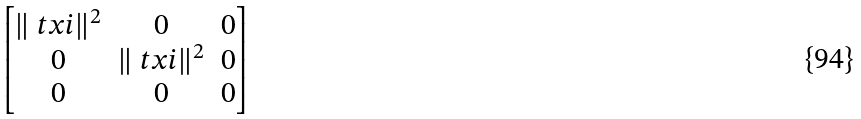Convert formula to latex. <formula><loc_0><loc_0><loc_500><loc_500>\begin{bmatrix} \| \ t x i \| ^ { 2 } & 0 & 0 \\ 0 & \| \ t x i \| ^ { 2 } & 0 \\ 0 & 0 & 0 \end{bmatrix}</formula> 